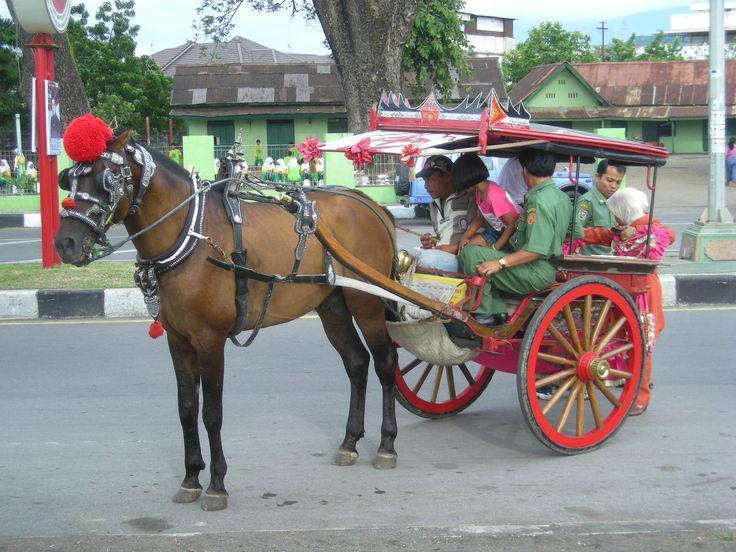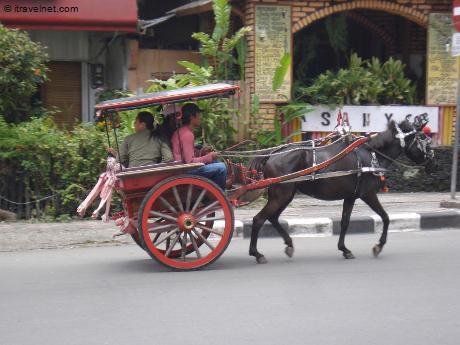The first image is the image on the left, the second image is the image on the right. Considering the images on both sides, is "An image shows a leftward-turned horse standing still with lowered head and hitched to a two-wheeled cart with a canopy top." valid? Answer yes or no. No. The first image is the image on the left, the second image is the image on the right. Given the left and right images, does the statement "The left and right image contains the same number of horses pulling a cart." hold true? Answer yes or no. Yes. 